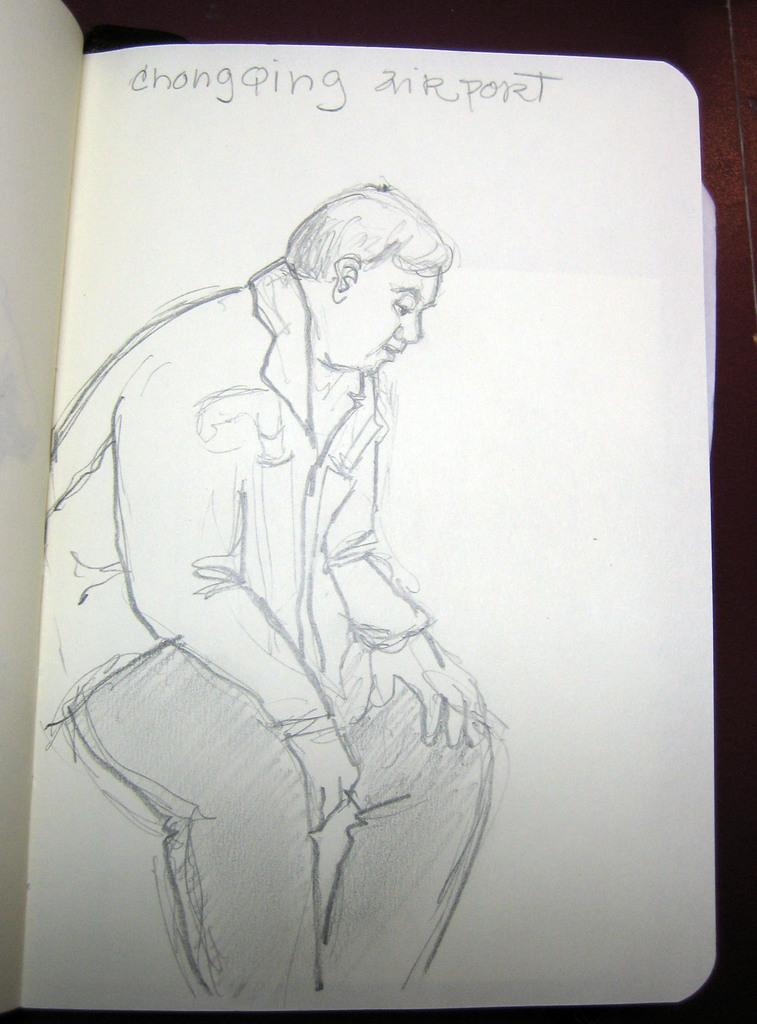What is depicted on the paper in the image? There is a pencil art on the paper. What else can be seen on the paper besides the pencil art? There is text on the top of the paper. What type of border surrounds the pencil art in the image? There is no border surrounding the pencil art in the image; it is directly on the paper. What is the purpose of the text on the top of the paper? The purpose of the text on the top of the paper cannot be determined from the image alone, as it may be a title, a caption, or a note related to the pencil art. 